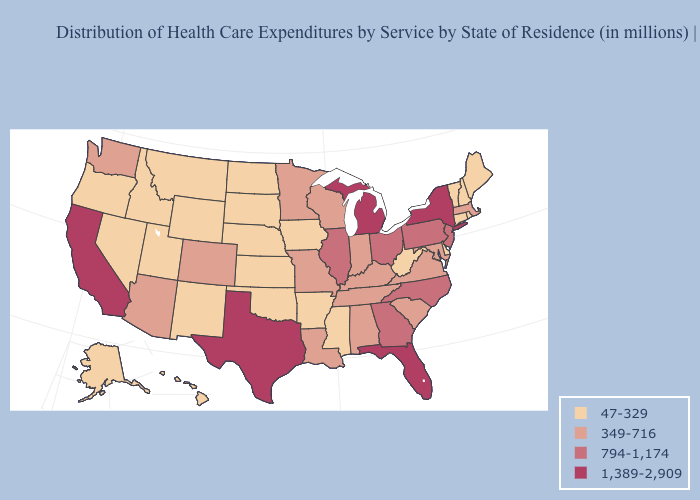Does the first symbol in the legend represent the smallest category?
Keep it brief. Yes. Does Washington have the same value as Virginia?
Concise answer only. Yes. Does Vermont have the lowest value in the USA?
Quick response, please. Yes. What is the lowest value in states that border New Mexico?
Short answer required. 47-329. Among the states that border Oregon , which have the highest value?
Short answer required. California. Does Louisiana have a higher value than Florida?
Answer briefly. No. What is the highest value in the USA?
Write a very short answer. 1,389-2,909. Name the states that have a value in the range 794-1,174?
Quick response, please. Georgia, Illinois, New Jersey, North Carolina, Ohio, Pennsylvania. What is the lowest value in the West?
Be succinct. 47-329. What is the value of Vermont?
Short answer required. 47-329. What is the highest value in states that border Oregon?
Be succinct. 1,389-2,909. Name the states that have a value in the range 47-329?
Concise answer only. Alaska, Arkansas, Connecticut, Delaware, Hawaii, Idaho, Iowa, Kansas, Maine, Mississippi, Montana, Nebraska, Nevada, New Hampshire, New Mexico, North Dakota, Oklahoma, Oregon, Rhode Island, South Dakota, Utah, Vermont, West Virginia, Wyoming. What is the value of West Virginia?
Answer briefly. 47-329. Does the map have missing data?
Keep it brief. No. What is the lowest value in the USA?
Short answer required. 47-329. 